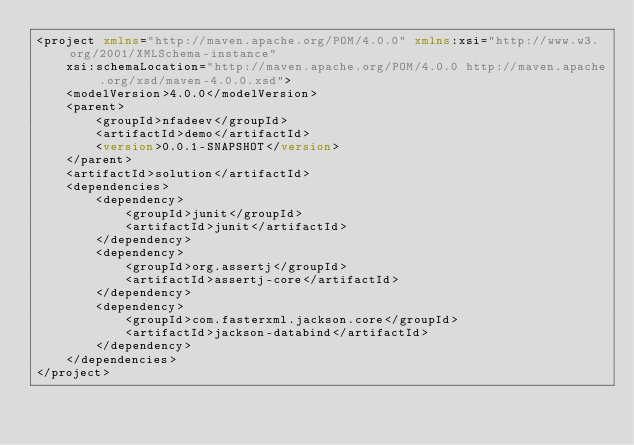Convert code to text. <code><loc_0><loc_0><loc_500><loc_500><_XML_><project xmlns="http://maven.apache.org/POM/4.0.0" xmlns:xsi="http://www.w3.org/2001/XMLSchema-instance"
	xsi:schemaLocation="http://maven.apache.org/POM/4.0.0 http://maven.apache.org/xsd/maven-4.0.0.xsd">
	<modelVersion>4.0.0</modelVersion>
	<parent>
		<groupId>nfadeev</groupId>
		<artifactId>demo</artifactId>
		<version>0.0.1-SNAPSHOT</version>
	</parent>
	<artifactId>solution</artifactId>
	<dependencies>
		<dependency>
			<groupId>junit</groupId>
			<artifactId>junit</artifactId>
		</dependency>
		<dependency>
            <groupId>org.assertj</groupId>
            <artifactId>assertj-core</artifactId>
        </dependency>
        <dependency>
            <groupId>com.fasterxml.jackson.core</groupId>
            <artifactId>jackson-databind</artifactId>
        </dependency>
	</dependencies>
</project></code> 